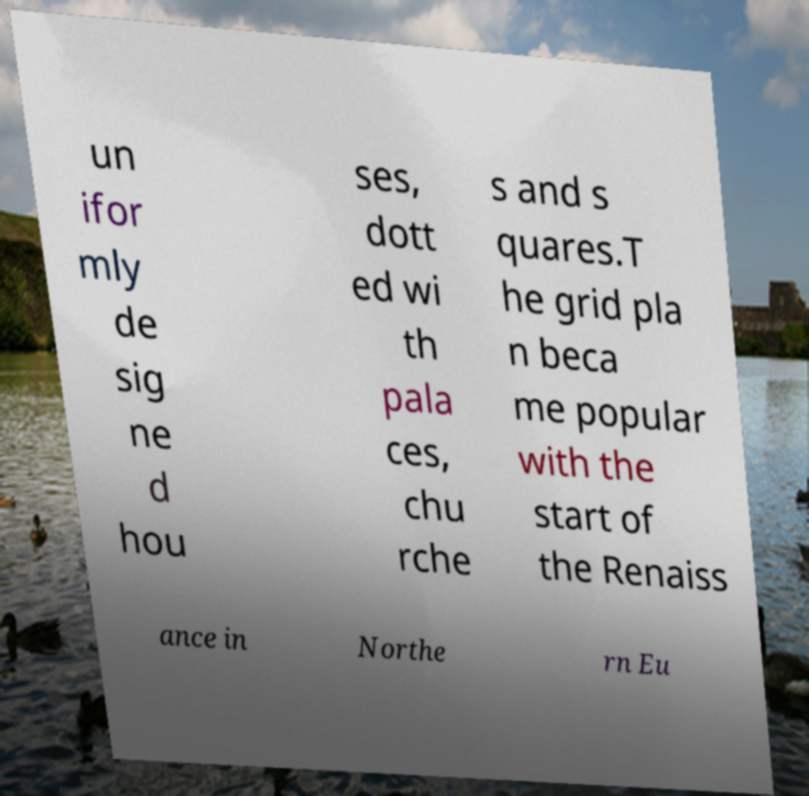What messages or text are displayed in this image? I need them in a readable, typed format. un ifor mly de sig ne d hou ses, dott ed wi th pala ces, chu rche s and s quares.T he grid pla n beca me popular with the start of the Renaiss ance in Northe rn Eu 